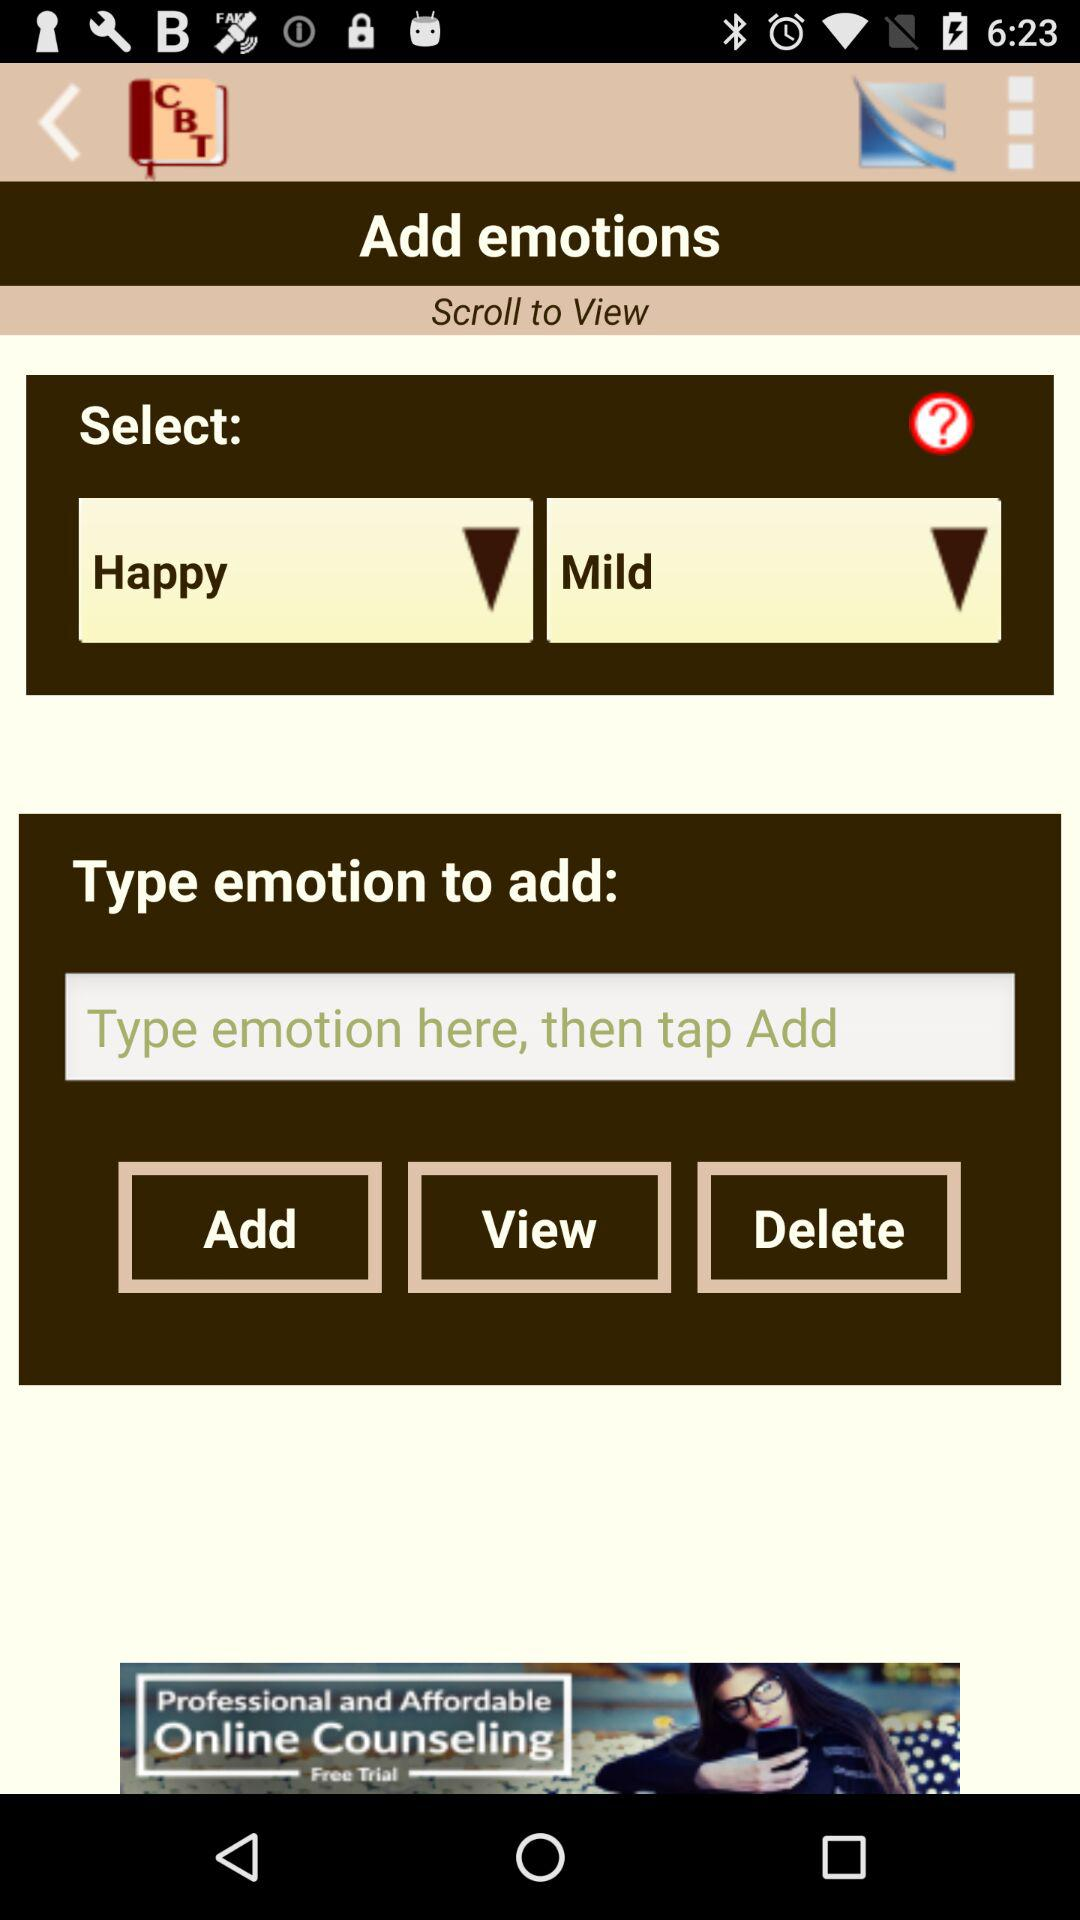Which mood has selected?
When the provided information is insufficient, respond with <no answer>. <no answer> 